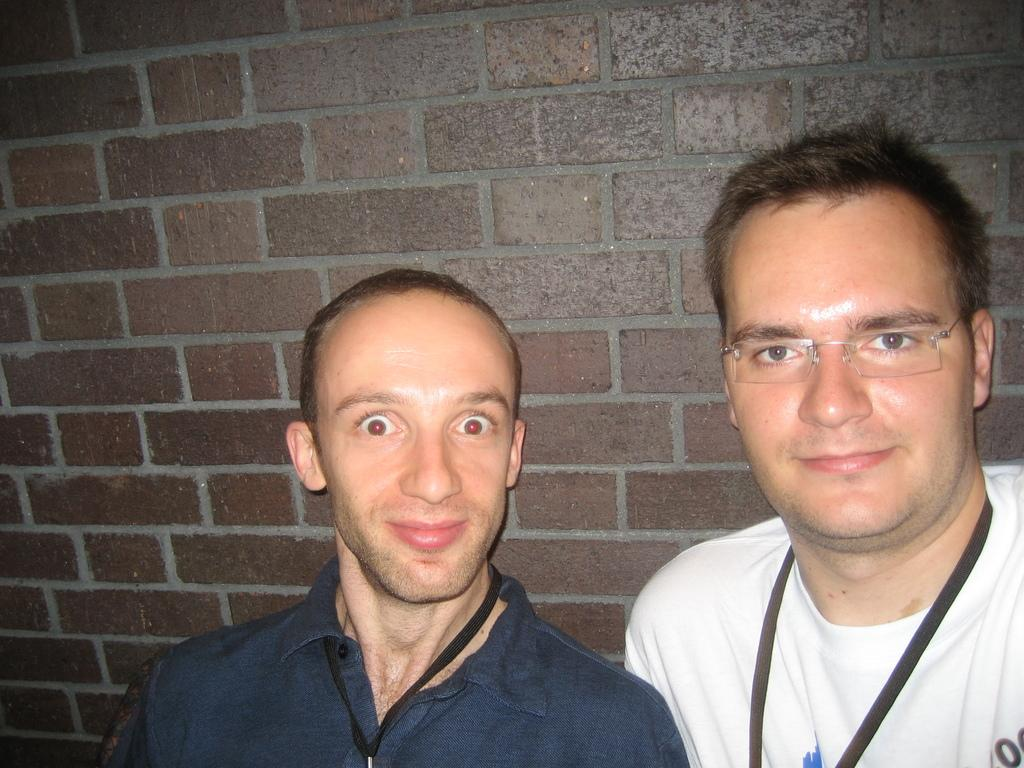How many people are in the image? There are two persons in the foreground of the image. What are the two persons doing in the image? The two persons are standing. What can be seen in the background of the image? There is a wall in the background of the image. What type of plants can be seen growing on the trousers of the persons in the image? There are no plants visible on the trousers of the persons in the image. Is there a fire burning in the background of the image? There is no fire present in the image. 